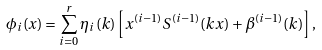Convert formula to latex. <formula><loc_0><loc_0><loc_500><loc_500>\phi _ { i } ( x ) = \sum _ { i = 0 } ^ { r } \eta _ { i } ( k ) \left [ x ^ { ( i - 1 ) } S ^ { ( i - 1 ) } ( k x ) + \beta ^ { ( i - 1 ) } ( k ) \right ] ,</formula> 